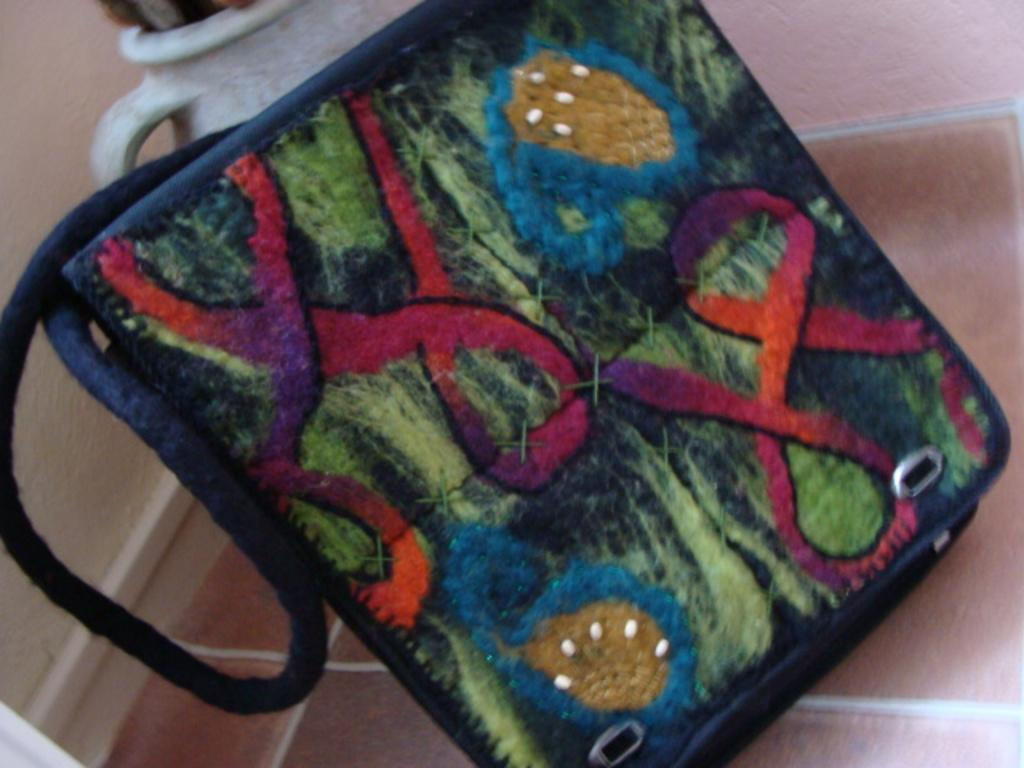What is placed on the floor in the image? There is a decorative handbag on the floor. What can be seen in the background of the image? There is a pot and a wall in the background. How does the handbag turn into a cat in the image? The handbag does not turn into a cat in the image; it remains a decorative handbag on the floor. 